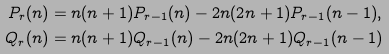Convert formula to latex. <formula><loc_0><loc_0><loc_500><loc_500>P _ { r } ( n ) & = n ( n + 1 ) P _ { r - 1 } ( n ) - 2 n ( 2 n + 1 ) P _ { r - 1 } ( n - 1 ) , \\ Q _ { r } ( n ) & = n ( n + 1 ) Q _ { r - 1 } ( n ) - 2 n ( 2 n + 1 ) Q _ { r - 1 } ( n - 1 )</formula> 